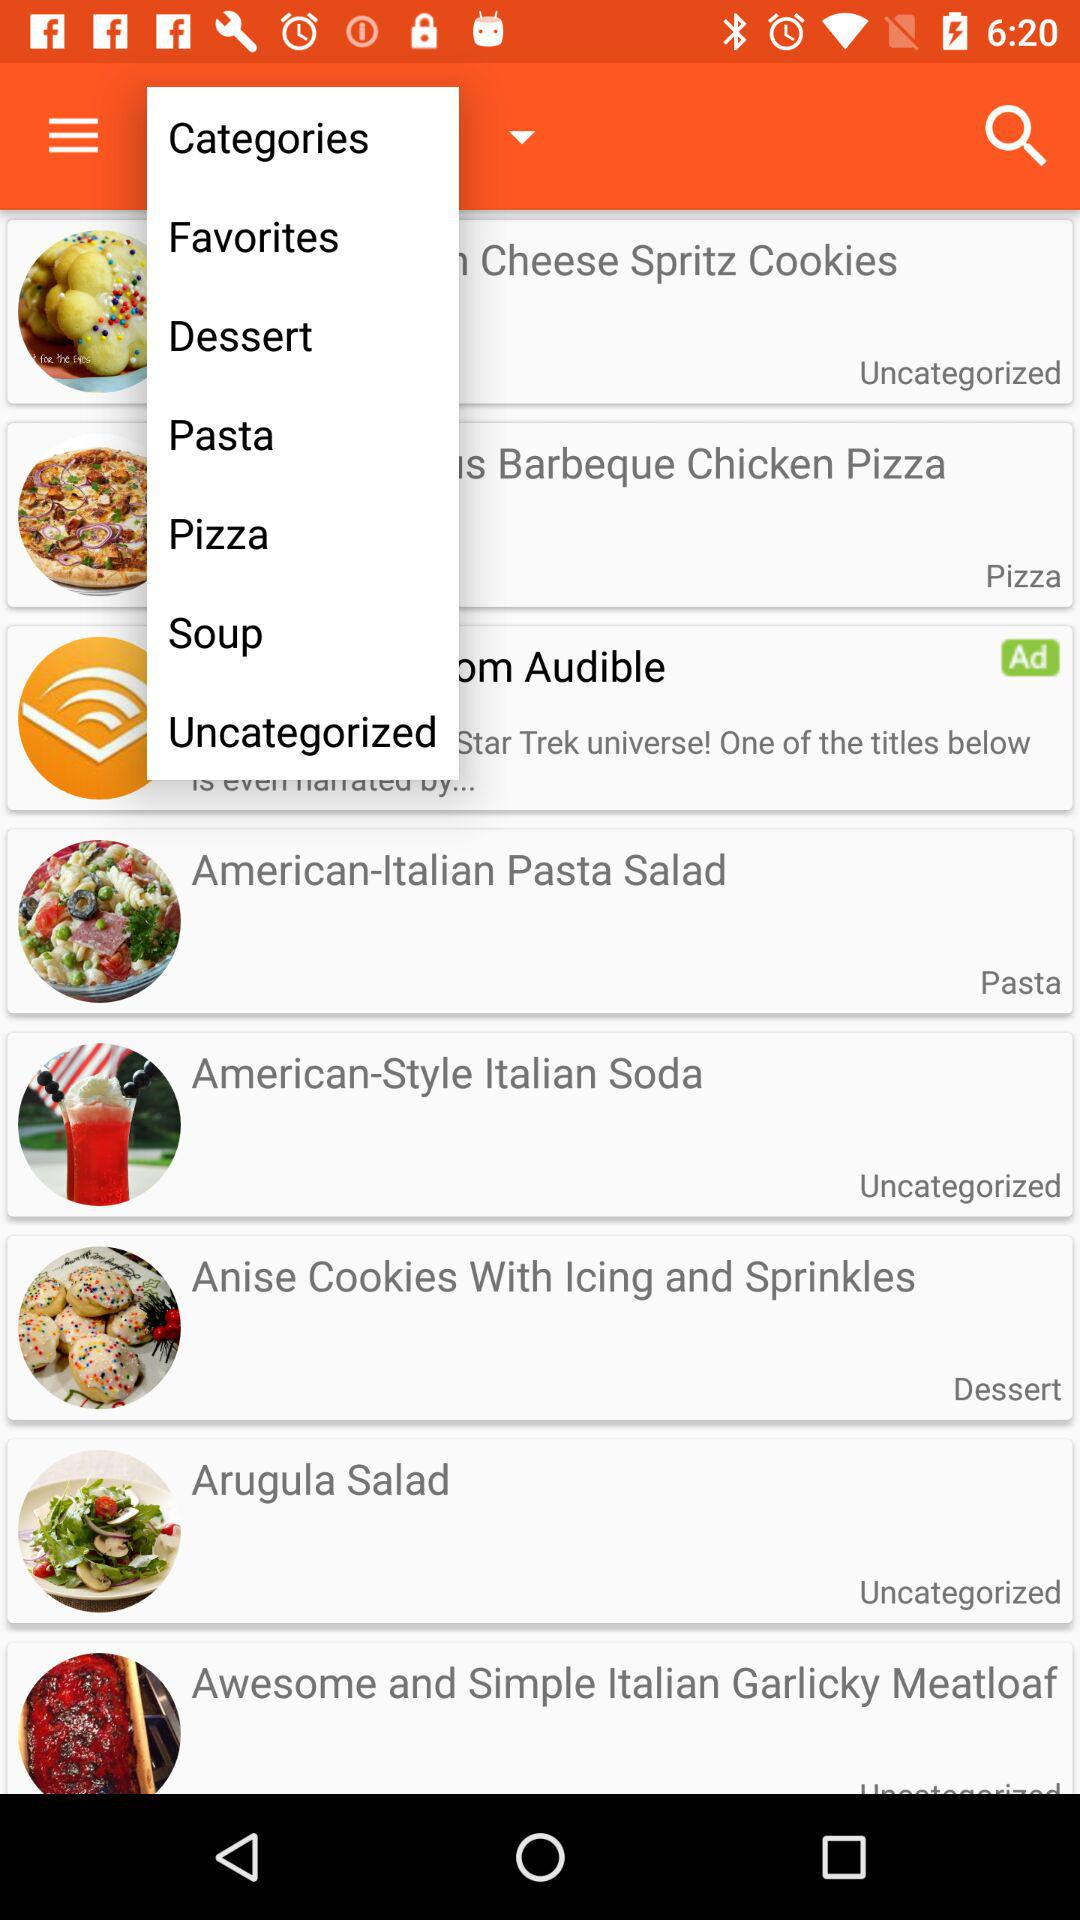Which category is selected?
When the provided information is insufficient, respond with <no answer>. <no answer> 